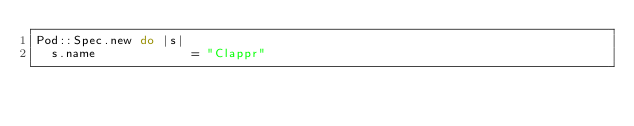<code> <loc_0><loc_0><loc_500><loc_500><_Ruby_>Pod::Spec.new do |s|
  s.name             = "Clappr"</code> 